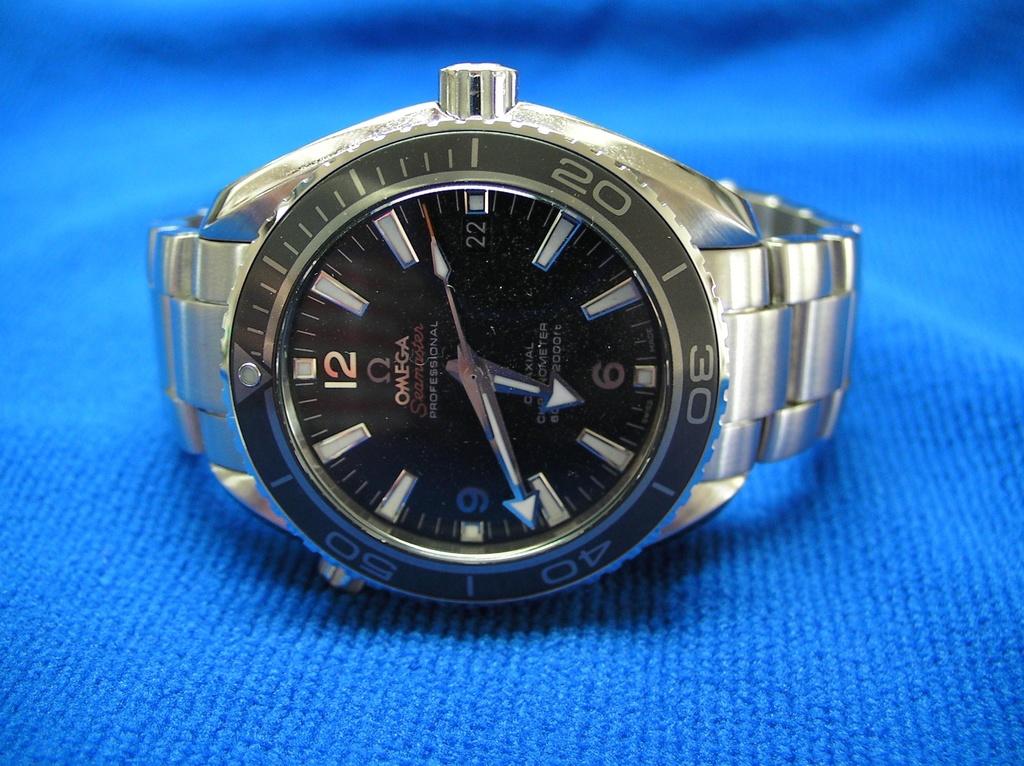What brand of watch is this?
Your answer should be very brief. Omega. What time is displayed on this watch?
Your response must be concise. 6:41. 